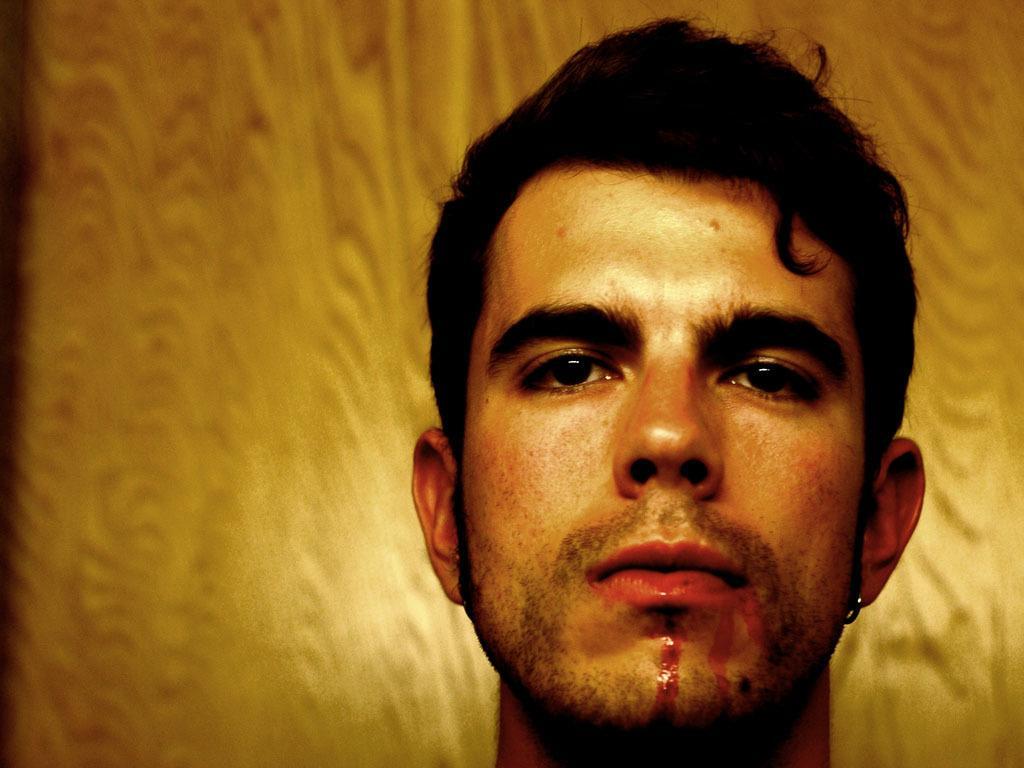Can you describe this image briefly? This is a zoomed in picture. In the foreground we can see a man. In the background there is an object seems to be the wall. 